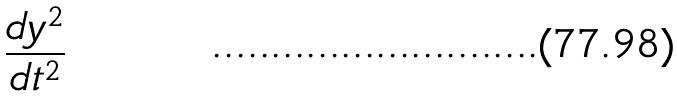Convert formula to latex. <formula><loc_0><loc_0><loc_500><loc_500>\frac { d y ^ { 2 } } { d t ^ { 2 } }</formula> 